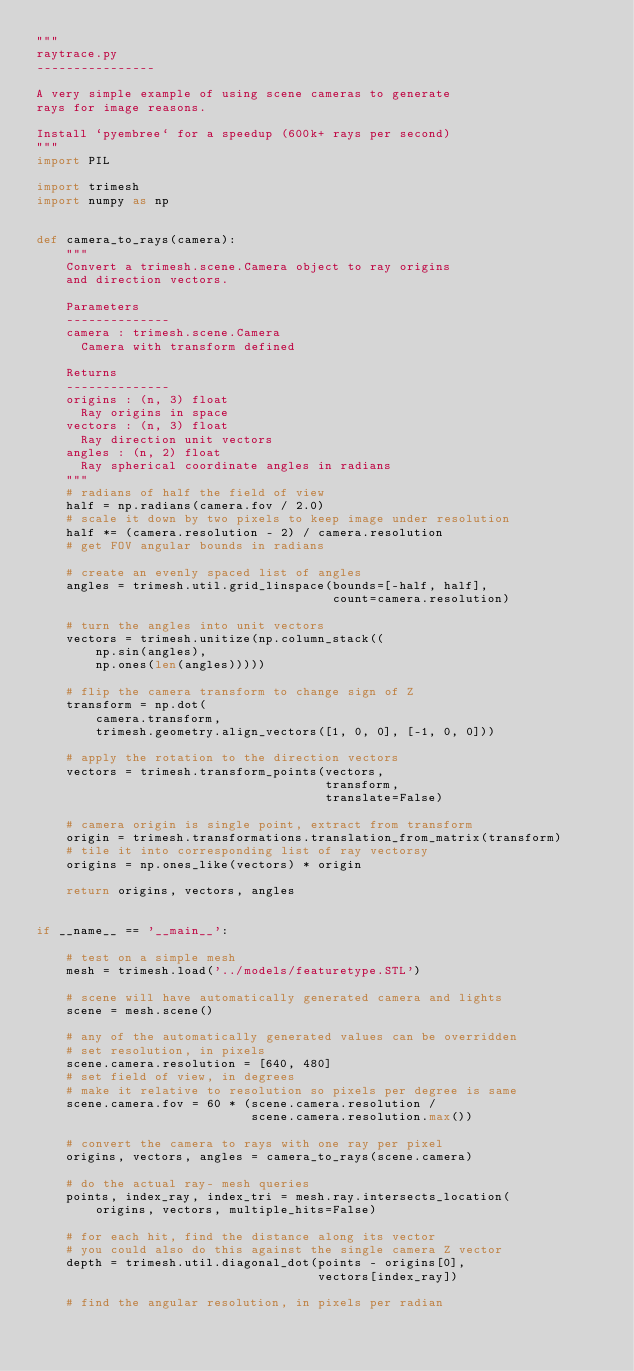<code> <loc_0><loc_0><loc_500><loc_500><_Python_>"""
raytrace.py
----------------

A very simple example of using scene cameras to generate
rays for image reasons.

Install `pyembree` for a speedup (600k+ rays per second)
"""
import PIL

import trimesh
import numpy as np


def camera_to_rays(camera):
    """
    Convert a trimesh.scene.Camera object to ray origins
    and direction vectors.

    Parameters
    --------------
    camera : trimesh.scene.Camera
      Camera with transform defined

    Returns
    --------------
    origins : (n, 3) float
      Ray origins in space
    vectors : (n, 3) float
      Ray direction unit vectors
    angles : (n, 2) float
      Ray spherical coordinate angles in radians
    """
    # radians of half the field of view
    half = np.radians(camera.fov / 2.0)
    # scale it down by two pixels to keep image under resolution
    half *= (camera.resolution - 2) / camera.resolution
    # get FOV angular bounds in radians

    # create an evenly spaced list of angles
    angles = trimesh.util.grid_linspace(bounds=[-half, half],
                                        count=camera.resolution)

    # turn the angles into unit vectors
    vectors = trimesh.unitize(np.column_stack((
        np.sin(angles),
        np.ones(len(angles)))))

    # flip the camera transform to change sign of Z
    transform = np.dot(
        camera.transform,
        trimesh.geometry.align_vectors([1, 0, 0], [-1, 0, 0]))

    # apply the rotation to the direction vectors
    vectors = trimesh.transform_points(vectors,
                                       transform,
                                       translate=False)

    # camera origin is single point, extract from transform
    origin = trimesh.transformations.translation_from_matrix(transform)
    # tile it into corresponding list of ray vectorsy
    origins = np.ones_like(vectors) * origin

    return origins, vectors, angles


if __name__ == '__main__':

    # test on a simple mesh
    mesh = trimesh.load('../models/featuretype.STL')

    # scene will have automatically generated camera and lights
    scene = mesh.scene()

    # any of the automatically generated values can be overridden
    # set resolution, in pixels
    scene.camera.resolution = [640, 480]
    # set field of view, in degrees
    # make it relative to resolution so pixels per degree is same
    scene.camera.fov = 60 * (scene.camera.resolution /
                             scene.camera.resolution.max())

    # convert the camera to rays with one ray per pixel
    origins, vectors, angles = camera_to_rays(scene.camera)

    # do the actual ray- mesh queries
    points, index_ray, index_tri = mesh.ray.intersects_location(
        origins, vectors, multiple_hits=False)

    # for each hit, find the distance along its vector
    # you could also do this against the single camera Z vector
    depth = trimesh.util.diagonal_dot(points - origins[0],
                                      vectors[index_ray])

    # find the angular resolution, in pixels per radian</code> 